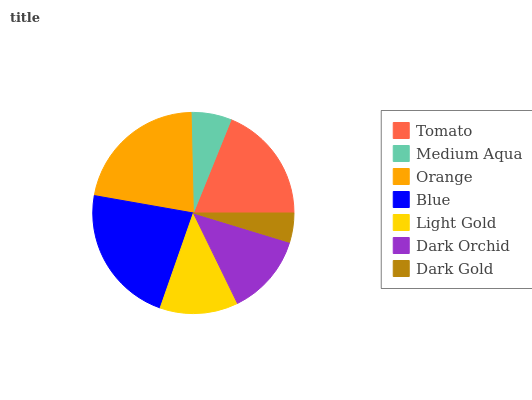Is Dark Gold the minimum?
Answer yes or no. Yes. Is Blue the maximum?
Answer yes or no. Yes. Is Medium Aqua the minimum?
Answer yes or no. No. Is Medium Aqua the maximum?
Answer yes or no. No. Is Tomato greater than Medium Aqua?
Answer yes or no. Yes. Is Medium Aqua less than Tomato?
Answer yes or no. Yes. Is Medium Aqua greater than Tomato?
Answer yes or no. No. Is Tomato less than Medium Aqua?
Answer yes or no. No. Is Dark Orchid the high median?
Answer yes or no. Yes. Is Dark Orchid the low median?
Answer yes or no. Yes. Is Light Gold the high median?
Answer yes or no. No. Is Medium Aqua the low median?
Answer yes or no. No. 